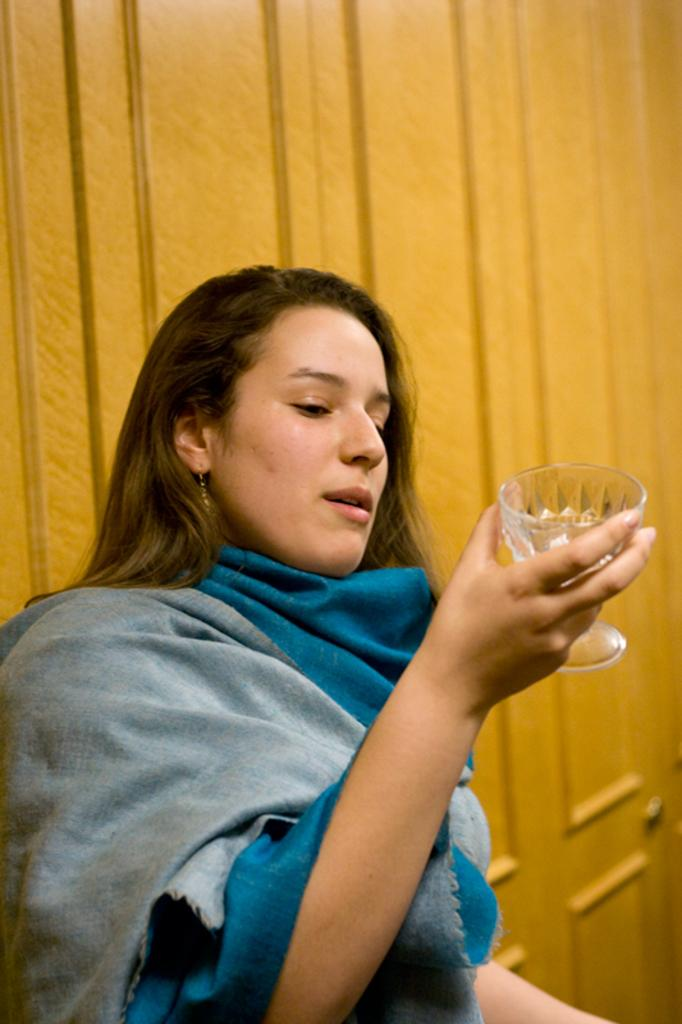Who is present in the image? There is a woman in the image. What is the woman wearing? The woman is wearing a shawl. What is the woman holding in her hand? The woman is holding a glass in her hand. What can be seen in the background of the image? There is a wooden object in the background of the image. What type of eggnog is the snail drinking in the image? There is no snail or eggnog present in the image. 